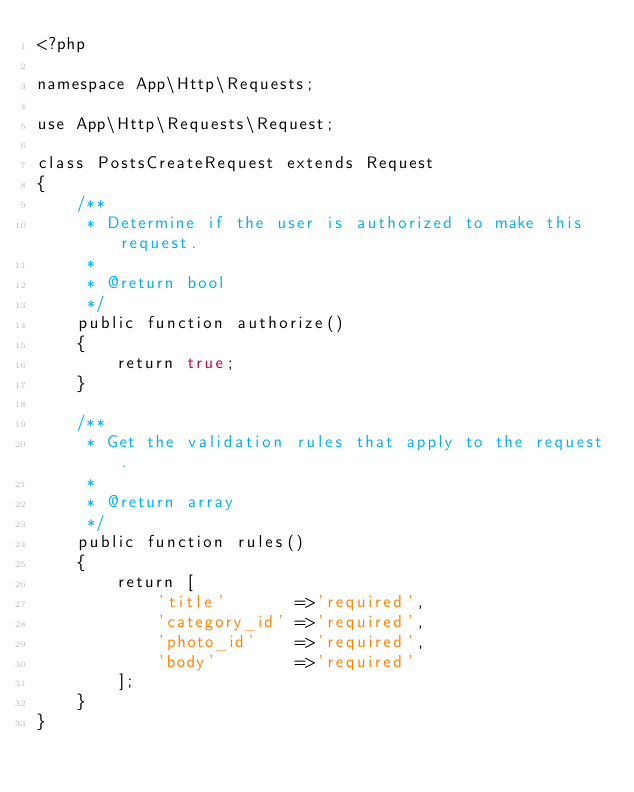<code> <loc_0><loc_0><loc_500><loc_500><_PHP_><?php

namespace App\Http\Requests;

use App\Http\Requests\Request;

class PostsCreateRequest extends Request
{
    /**
     * Determine if the user is authorized to make this request.
     *
     * @return bool
     */
    public function authorize()
    {
        return true;
    }

    /**
     * Get the validation rules that apply to the request.
     *
     * @return array
     */
    public function rules()
    {
        return [
            'title'       =>'required',
            'category_id' =>'required',
            'photo_id'    =>'required',            
            'body'        =>'required'
        ];
    }
}
</code> 